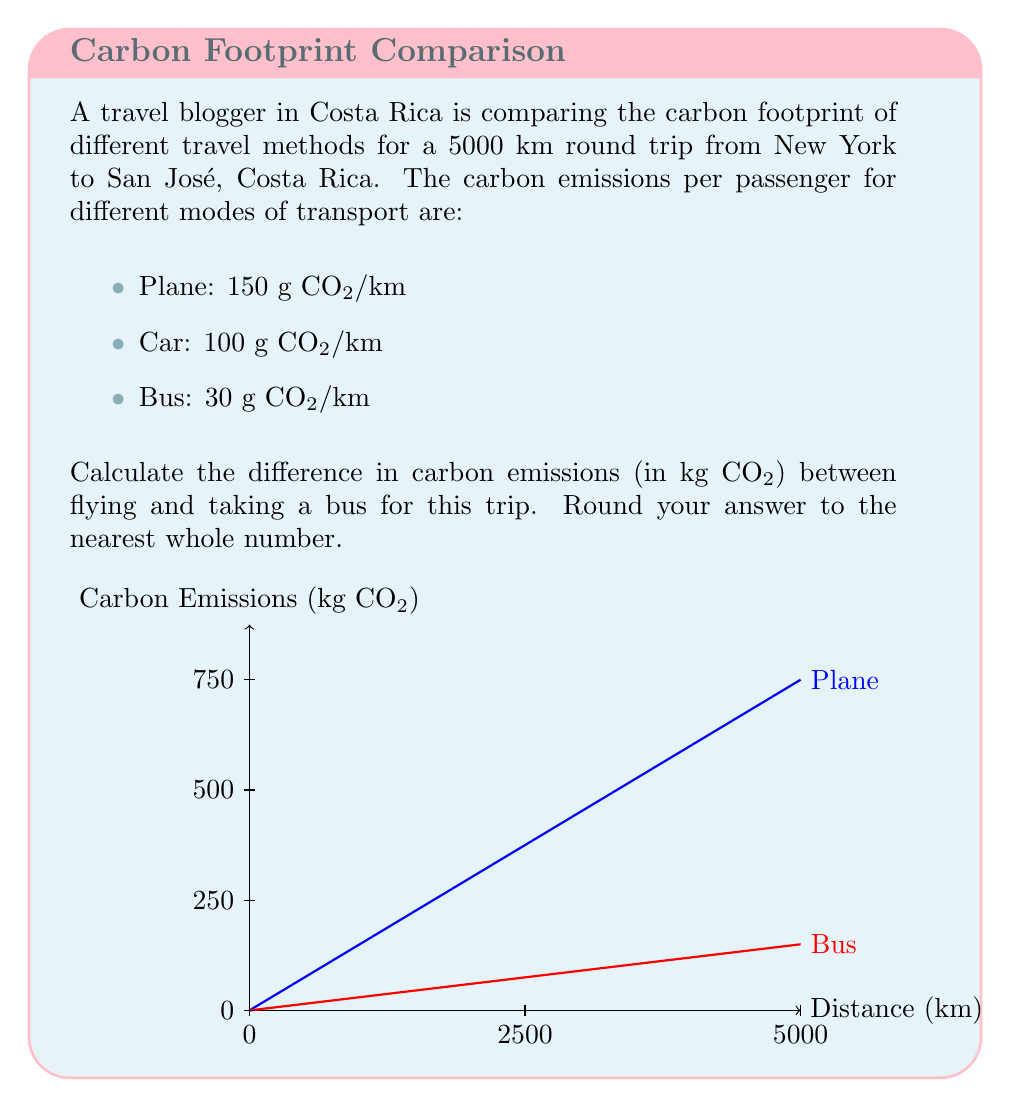What is the answer to this math problem? Let's approach this step-by-step:

1) First, calculate the carbon emissions for flying:
   $$E_{plane} = 150 \frac{g}{km} \times 5000 \text{ km} = 750,000 \text{ g CO₂}$$

2) Convert this to kg:
   $$E_{plane} = 750,000 \text{ g} \times \frac{1 \text{ kg}}{1000 \text{ g}} = 750 \text{ kg CO₂}$$

3) Now, calculate the carbon emissions for taking a bus:
   $$E_{bus} = 30 \frac{g}{km} \times 5000 \text{ km} = 150,000 \text{ g CO₂}$$

4) Convert this to kg:
   $$E_{bus} = 150,000 \text{ g} \times \frac{1 \text{ kg}}{1000 \text{ g}} = 150 \text{ kg CO₂}$$

5) Calculate the difference:
   $$\Delta E = E_{plane} - E_{bus} = 750 \text{ kg} - 150 \text{ kg} = 600 \text{ kg CO₂}$$

6) The question asks to round to the nearest whole number, but 600 is already a whole number, so no rounding is necessary.
Answer: 600 kg CO₂ 